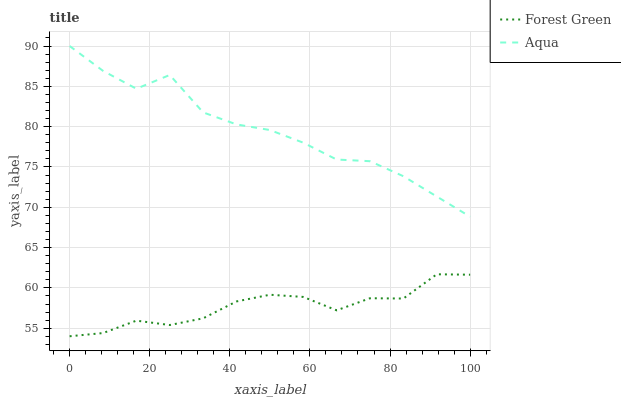Does Aqua have the minimum area under the curve?
Answer yes or no. No. Is Aqua the smoothest?
Answer yes or no. No. Does Aqua have the lowest value?
Answer yes or no. No. Is Forest Green less than Aqua?
Answer yes or no. Yes. Is Aqua greater than Forest Green?
Answer yes or no. Yes. Does Forest Green intersect Aqua?
Answer yes or no. No. 